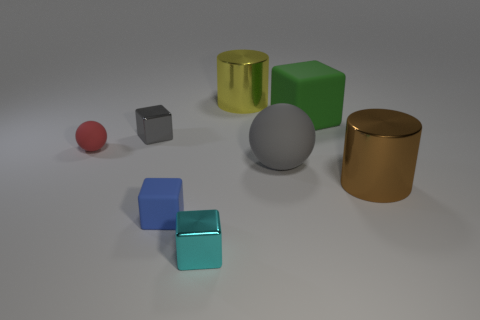What shape is the small object that is the same color as the large rubber ball?
Your response must be concise. Cube. The metal object that is the same color as the big sphere is what size?
Make the answer very short. Small. There is a brown metal thing that is the same shape as the big yellow metallic object; what is its size?
Offer a very short reply. Large. There is another metal thing that is the same shape as the yellow object; what is its color?
Offer a very short reply. Brown. What number of large gray balls have the same material as the tiny blue thing?
Provide a short and direct response. 1. Does the tiny rubber thing that is behind the brown thing have the same shape as the tiny rubber thing that is in front of the large gray matte object?
Provide a succinct answer. No. There is a big shiny object that is to the right of the large rubber block; what color is it?
Offer a very short reply. Brown. Is there another tiny blue matte object of the same shape as the tiny blue thing?
Offer a very short reply. No. What is the material of the blue cube?
Your response must be concise. Rubber. How big is the matte object that is both behind the big brown object and on the left side of the cyan shiny cube?
Give a very brief answer. Small. 